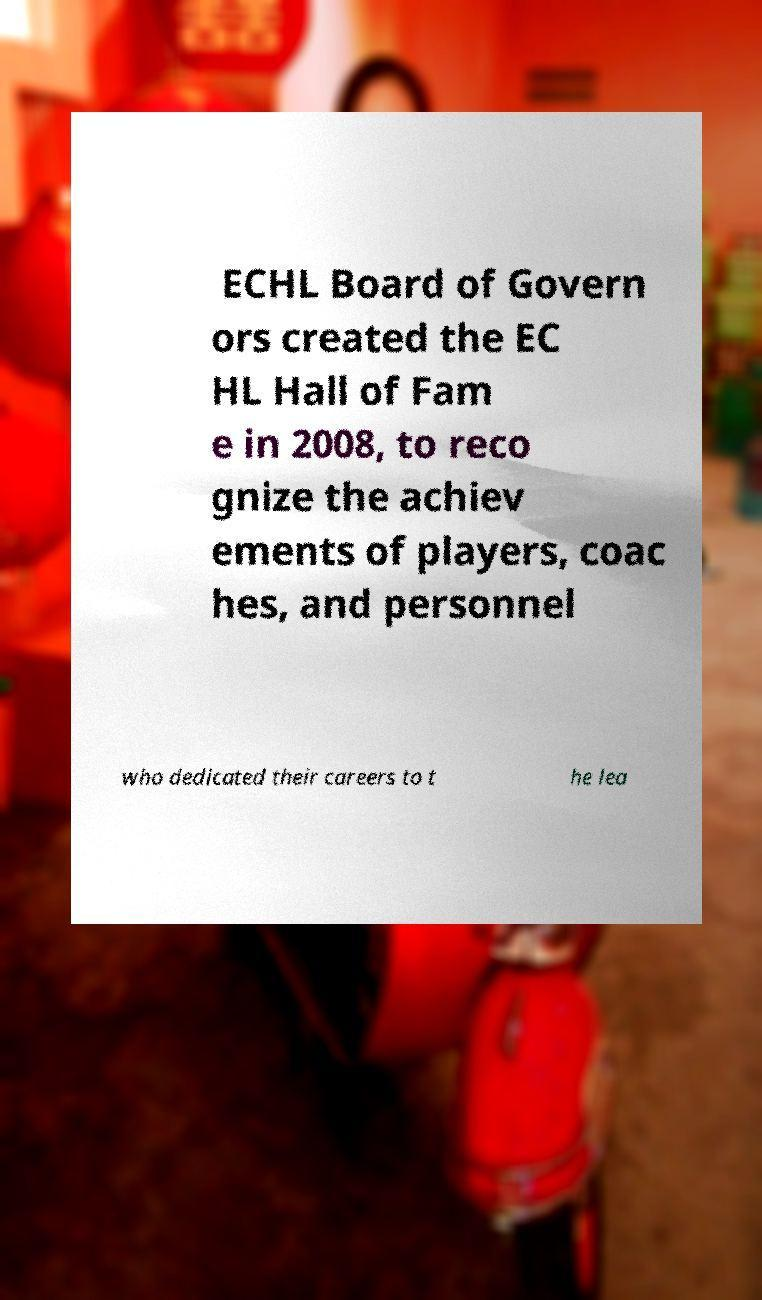Can you accurately transcribe the text from the provided image for me? ECHL Board of Govern ors created the EC HL Hall of Fam e in 2008, to reco gnize the achiev ements of players, coac hes, and personnel who dedicated their careers to t he lea 